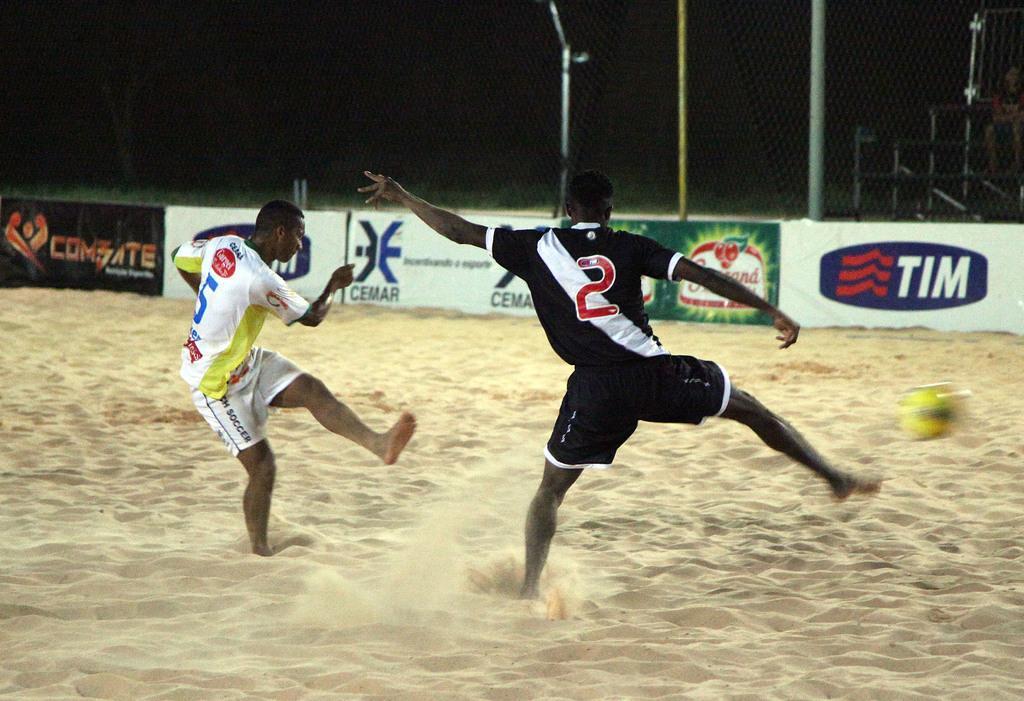Could you give a brief overview of what you see in this image? This is the picture of a playground. In this image there are two persons standing and there is a yellow color ball in the air. At the back there are hoardings and there are poles behind the fence. At the top there is sky. At the bottom there is sand. 